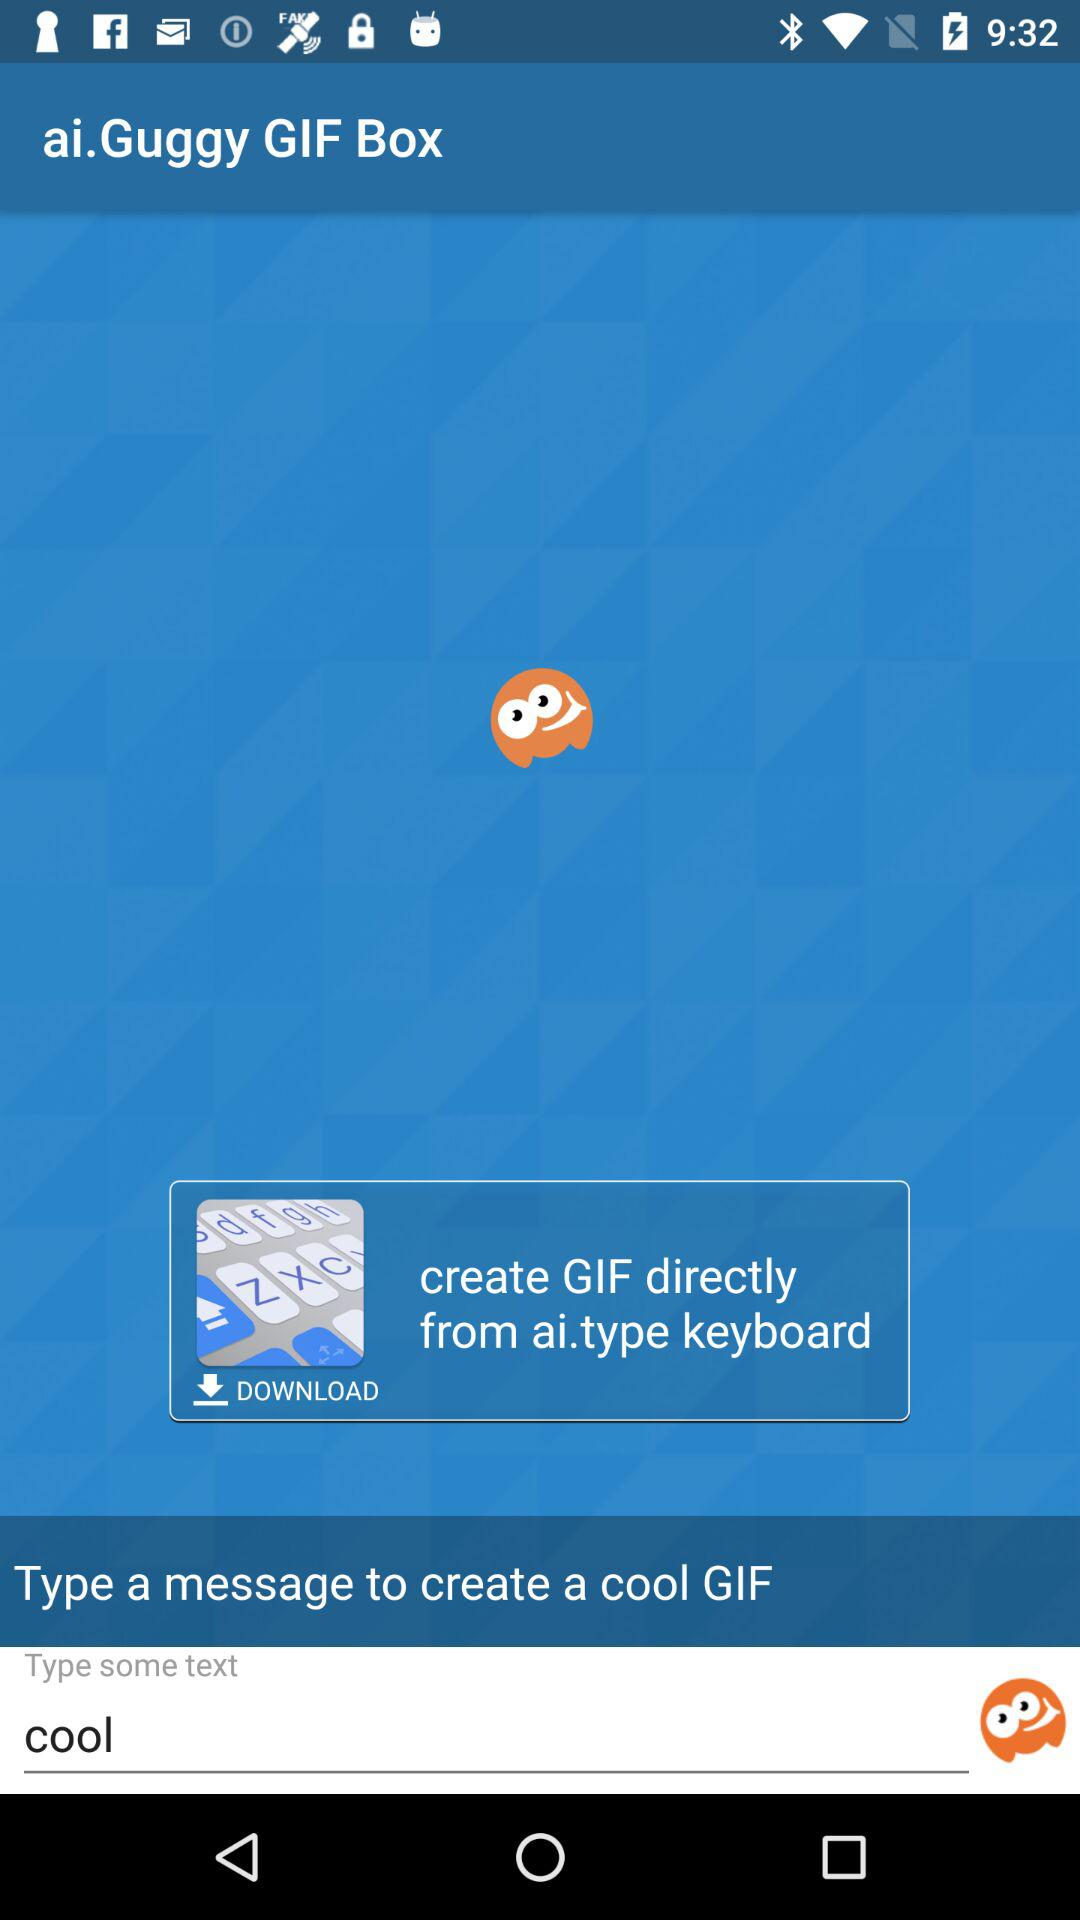What is the name of the application? The name of the application is "ai.Guggy GIF Box". 